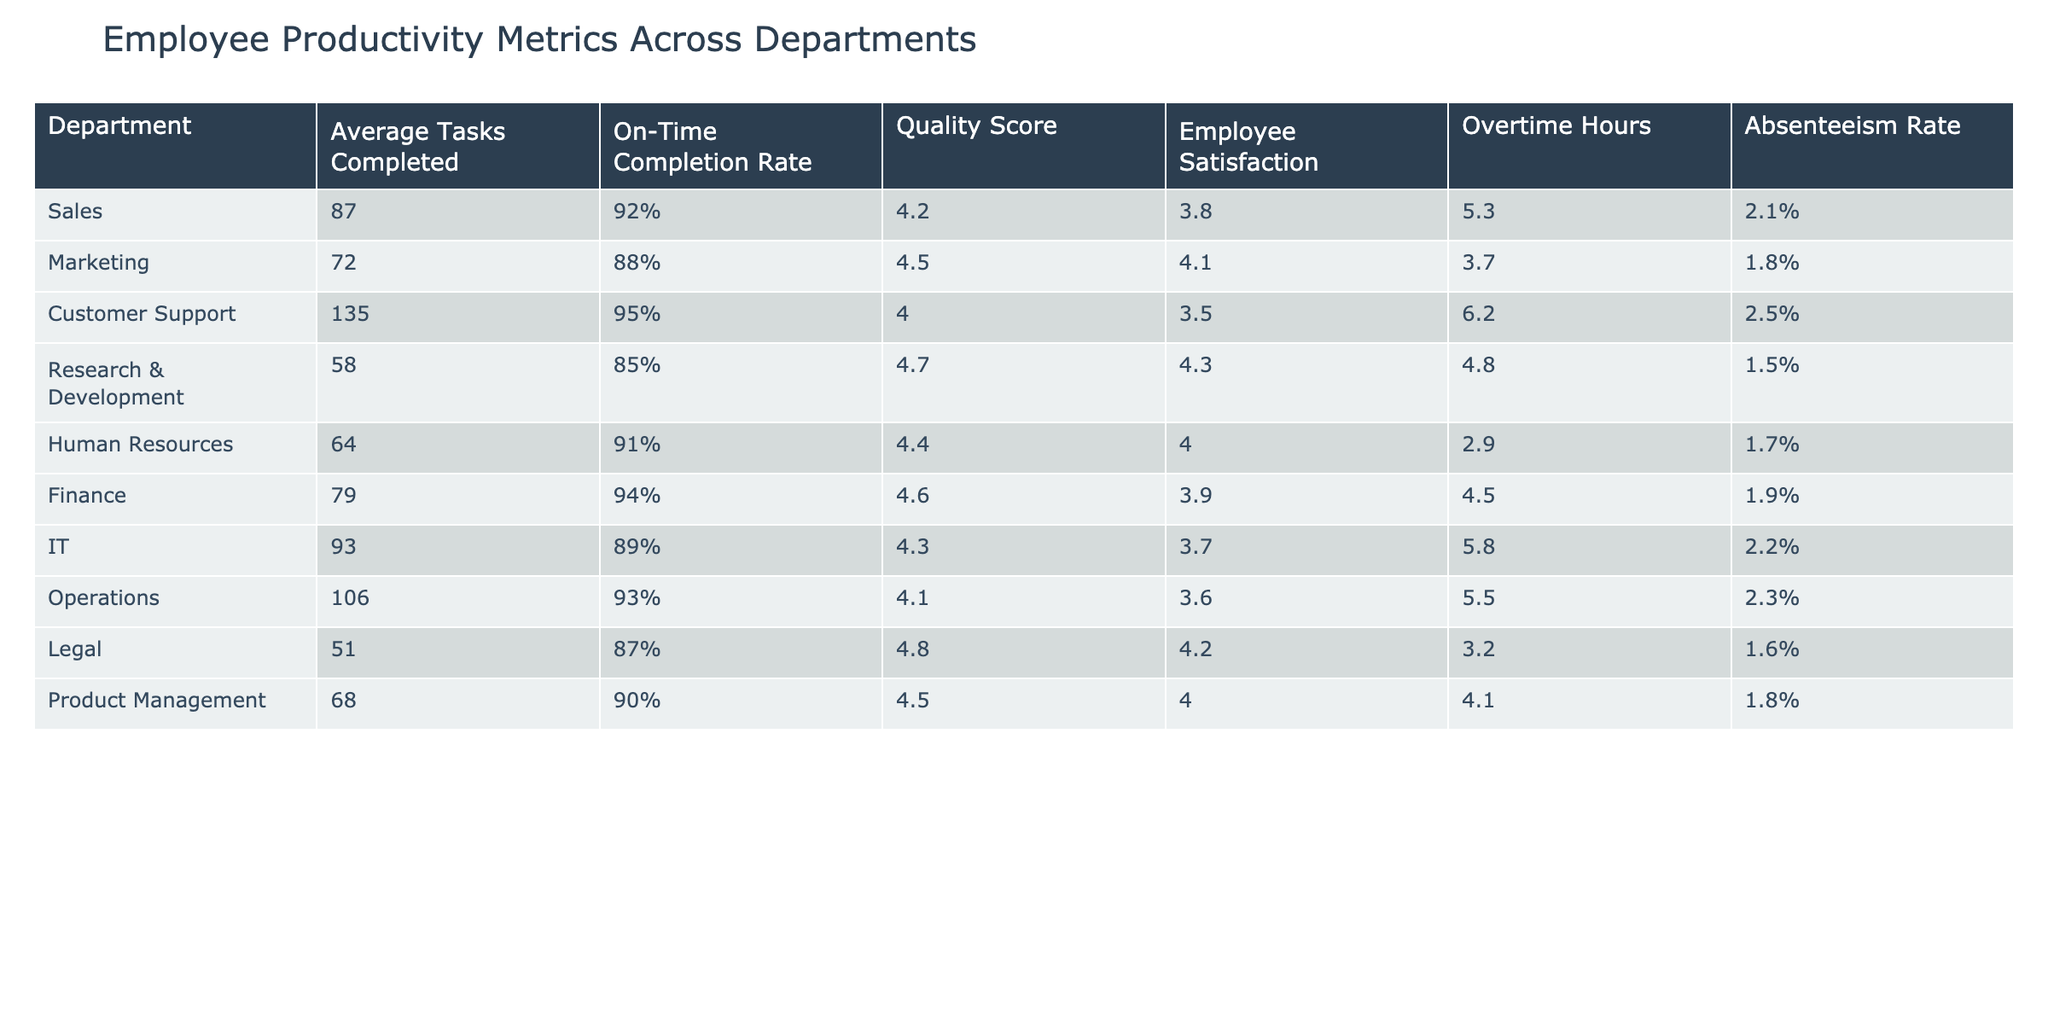What department has the highest average tasks completed? By scanning the "Average Tasks Completed" column, Customer Support has the highest value of 135.
Answer: Customer Support What is the quality score of the Finance department? From the "Quality Score" column, the Finance department has a quality score of 4.6.
Answer: 4.6 Does the Marketing department have a higher employee satisfaction score than the Human Resources department? The Marketing department has a satisfaction score of 4.1, while Human Resources has a satisfaction score of 4.0. Therefore, yes, Marketing is higher.
Answer: Yes What is the difference in the on-time completion rates between Sales and Research & Development? Sales has an on-time completion rate of 92% and Research & Development has 85%. To find the difference, subtract 85 from 92 which gives 7.
Answer: 7% Which department has the lowest absenteeism rate, and what is that rate? Looking at the "Absenteeism Rate" column, the Research & Development department has the lowest rate at 1.5%.
Answer: Research & Development, 1.5% If we consider the average tasks completed for Sales and IT, which department has a better average, and what is the difference? Sales completes an average of 87 tasks, while IT completes 93 tasks. The difference is 93 minus 87, which results in 6.
Answer: IT is better, difference of 6 How many departments have an on-time completion rate of 90% or higher? Checking the "On-Time Completion Rate" column, the departments with rates of 90% or higher are Sales, Customer Support, Finance, Operations, and Human Resources, totaling 5 departments.
Answer: 5 departments Which department has the highest level of overtime hours, and what is that level? Upon reviewing the "Overtime Hours" column, Customer Support has the highest level at 6.2 hours.
Answer: Customer Support, 6.2 hours Is it true that all departments have an average tasks completed over 50? After reviewing the "Average Tasks Completed" column, all departments, except for Research & Development with 58, meet the criteria. Therefore, the statement is false.
Answer: No 